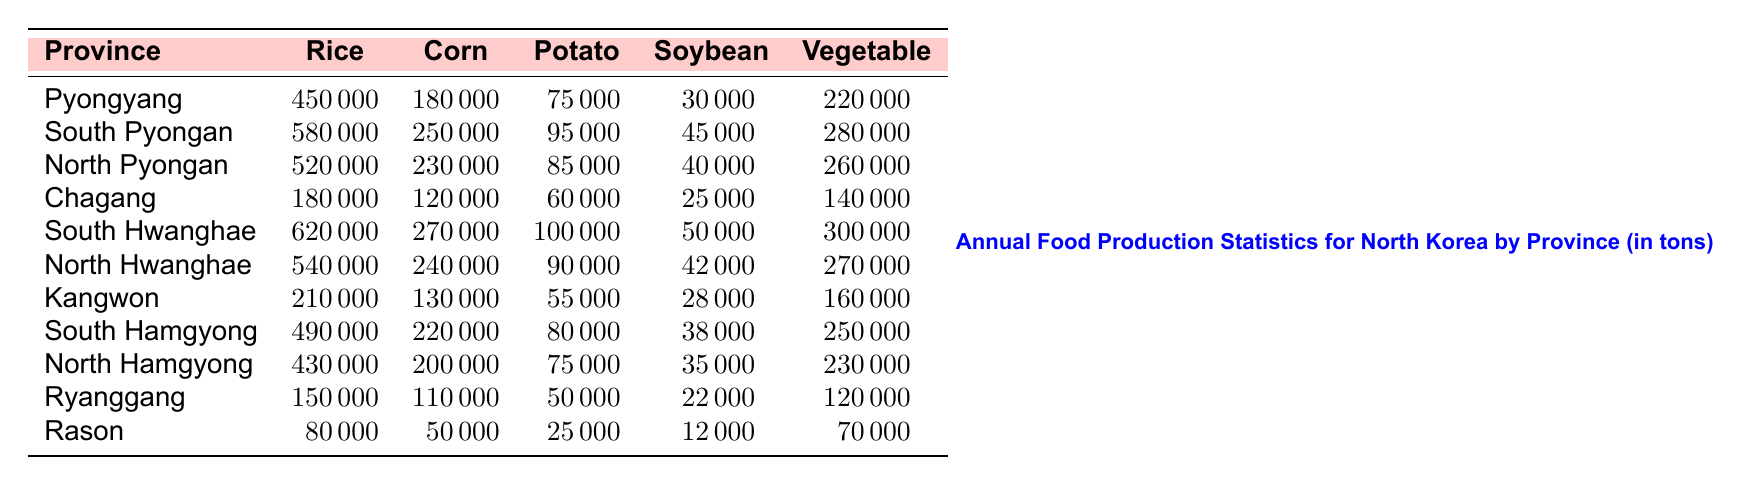What is the total rice production in South Hwanghae? From the table, South Hwanghae's rice production is listed as 620,000 tons.
Answer: 620000 Which province produced the highest amount of corn? The table shows that South Hwanghae produced 270,000 tons of corn, which is the highest compared to other provinces.
Answer: South Hwanghae Calculate the total vegetable production for North and South Hamgyong provinces combined. North Hamgyong produced 230,000 tons, and South Hamgyong produced 250,000 tons. Adding these gives 230,000 + 250,000 = 480,000 tons.
Answer: 480000 Is the potato production in North Hwanghae greater than in Ryanggang? North Hwanghae's potato production is 90,000 tons, while Ryanggang's production is 50,000 tons. Since 90,000 > 50,000, the statement is true.
Answer: Yes Which province has the smallest total food production? First, calculate the total production for each province by adding their food production values. Rason's total production (80,000 + 50,000 + 25,000 + 12,000 + 70,000) = 237,000 tons is smaller than any other province's total.
Answer: Rason What is the average soybean production across all provinces? To find the average, sum all soybean productions: (30,000 + 45,000 + 40,000 + 25,000 + 50,000 + 42,000 + 28,000 + 38,000 + 35,000 + 22,000 + 12,000) = 392,000 tons. There are 11 provinces, so the average is 392,000 / 11 = 35,636 tons.
Answer: 35636 Which province has the highest production of potatoes? By examining the potato production figures, South Hwanghae produced the highest at 100,000 tons, compared to other provinces.
Answer: South Hwanghae If we consider only rice and corn production, which province has the highest total? Sum the rice and corn production for each province. The highest total is South Pyongan with 580,000 tons of rice + 250,000 tons of corn = 830,000 tons.
Answer: South Pyongan Does Pyongyang produce more rice than North Hamgyong? Pyongyang produces 450,000 tons of rice, while North Hamgyong produces 430,000 tons. Since 450,000 > 430,000, the answer is yes.
Answer: Yes What is the total food production for North Pyongan? Calculate by summing all categories: 520,000 (rice) + 230,000 (corn) + 85,000 (potato) + 40,000 (soybean) + 260,000 (vegetable) = 1,135,000 tons.
Answer: 1135000 